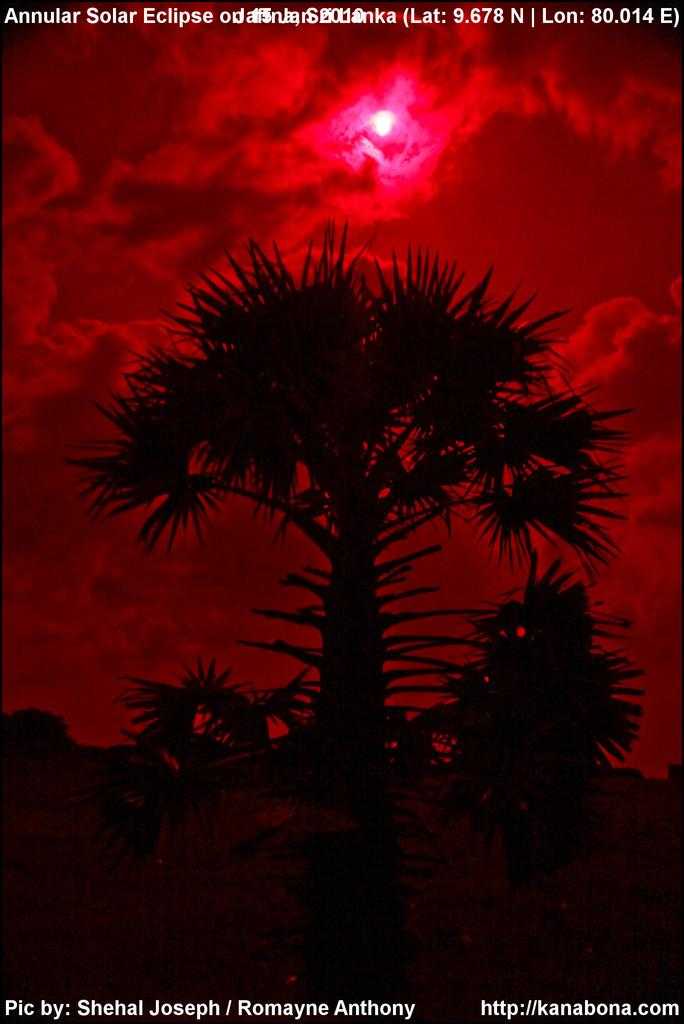What type of vegetation can be seen in the image? There are trees in the image. What is the condition of the sky in the image? The sky is cloudy in the image. What celestial body is visible in the image? The moon is visible in the image. What type of apparatus is being used to sail in the image? There is no apparatus or sailing activity present in the image; it features trees, a cloudy sky, and the moon. Where is the dock located in the image? There is no dock present in the image. 